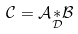Convert formula to latex. <formula><loc_0><loc_0><loc_500><loc_500>\mathcal { C = A } \underset { \mathcal { D } } { \mathcal { \ast } } \mathcal { B }</formula> 